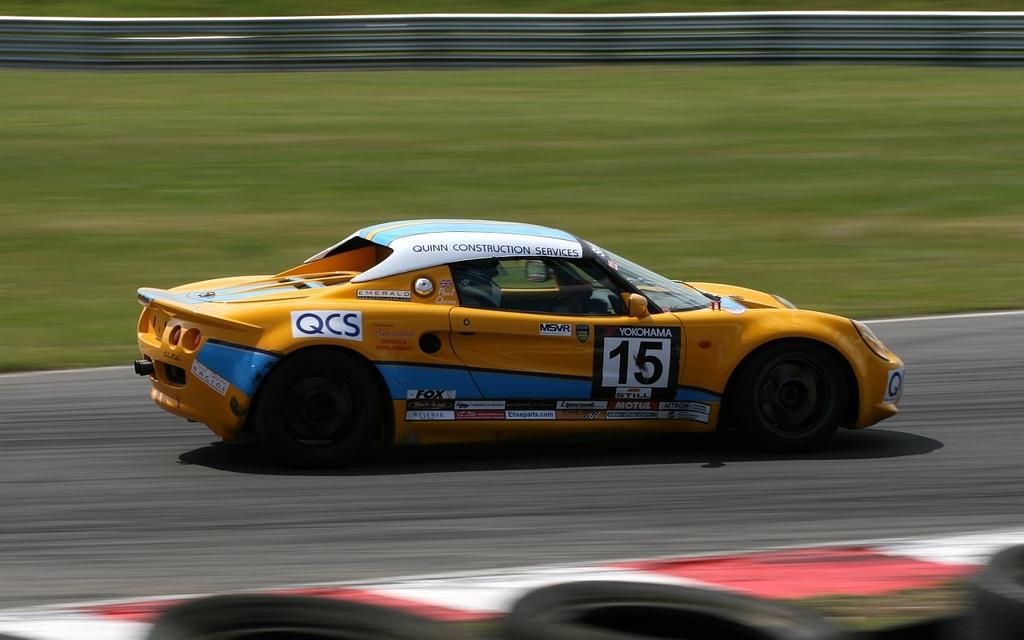Describe this image in one or two sentences. In this image I can see a car which is in orange and blue color, and I can see a person inside the car, background I can see the grass in green color. 